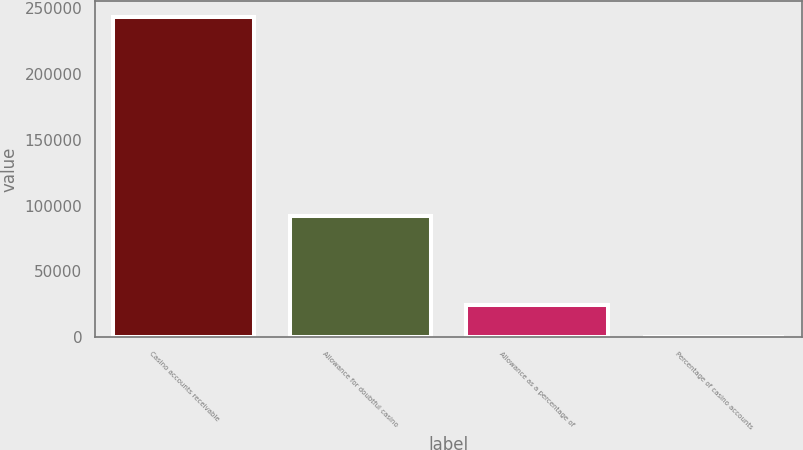<chart> <loc_0><loc_0><loc_500><loc_500><bar_chart><fcel>Casino accounts receivable<fcel>Allowance for doubtful casino<fcel>Allowance as a percentage of<fcel>Percentage of casino accounts<nl><fcel>243600<fcel>92278<fcel>24378.9<fcel>21<nl></chart> 